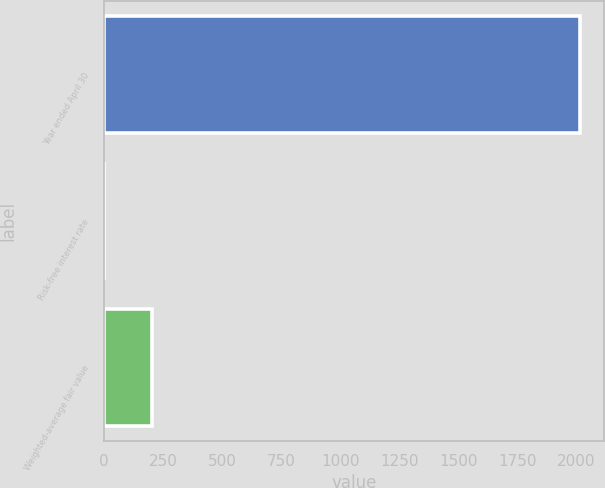<chart> <loc_0><loc_0><loc_500><loc_500><bar_chart><fcel>Year ended April 30<fcel>Risk-free interest rate<fcel>Weighted-average fair value<nl><fcel>2015<fcel>0.81<fcel>202.23<nl></chart> 